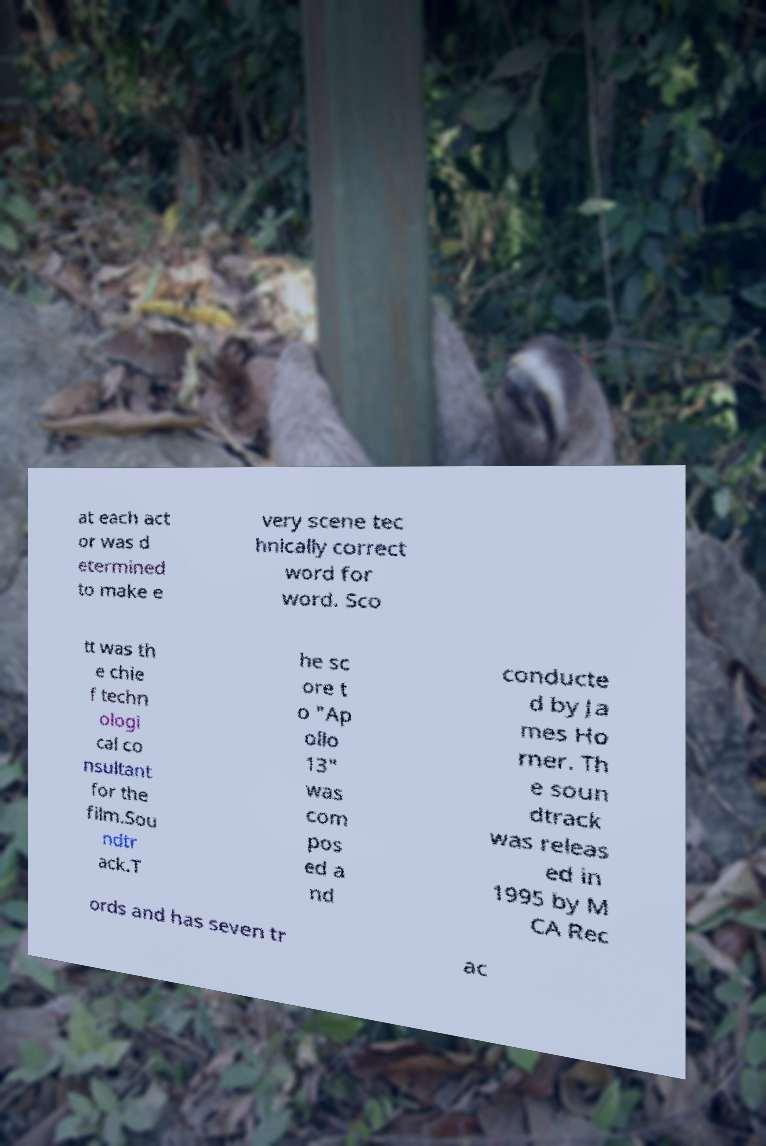Could you extract and type out the text from this image? at each act or was d etermined to make e very scene tec hnically correct word for word. Sco tt was th e chie f techn ologi cal co nsultant for the film.Sou ndtr ack.T he sc ore t o "Ap ollo 13" was com pos ed a nd conducte d by Ja mes Ho rner. Th e soun dtrack was releas ed in 1995 by M CA Rec ords and has seven tr ac 